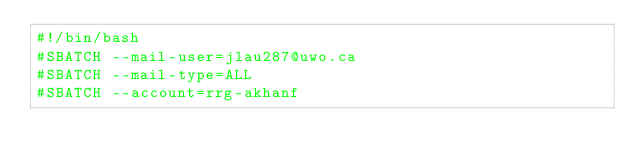<code> <loc_0><loc_0><loc_500><loc_500><_Bash_>#!/bin/bash
#SBATCH --mail-user=jlau287@uwo.ca
#SBATCH --mail-type=ALL
#SBATCH --account=rrg-akhanf</code> 